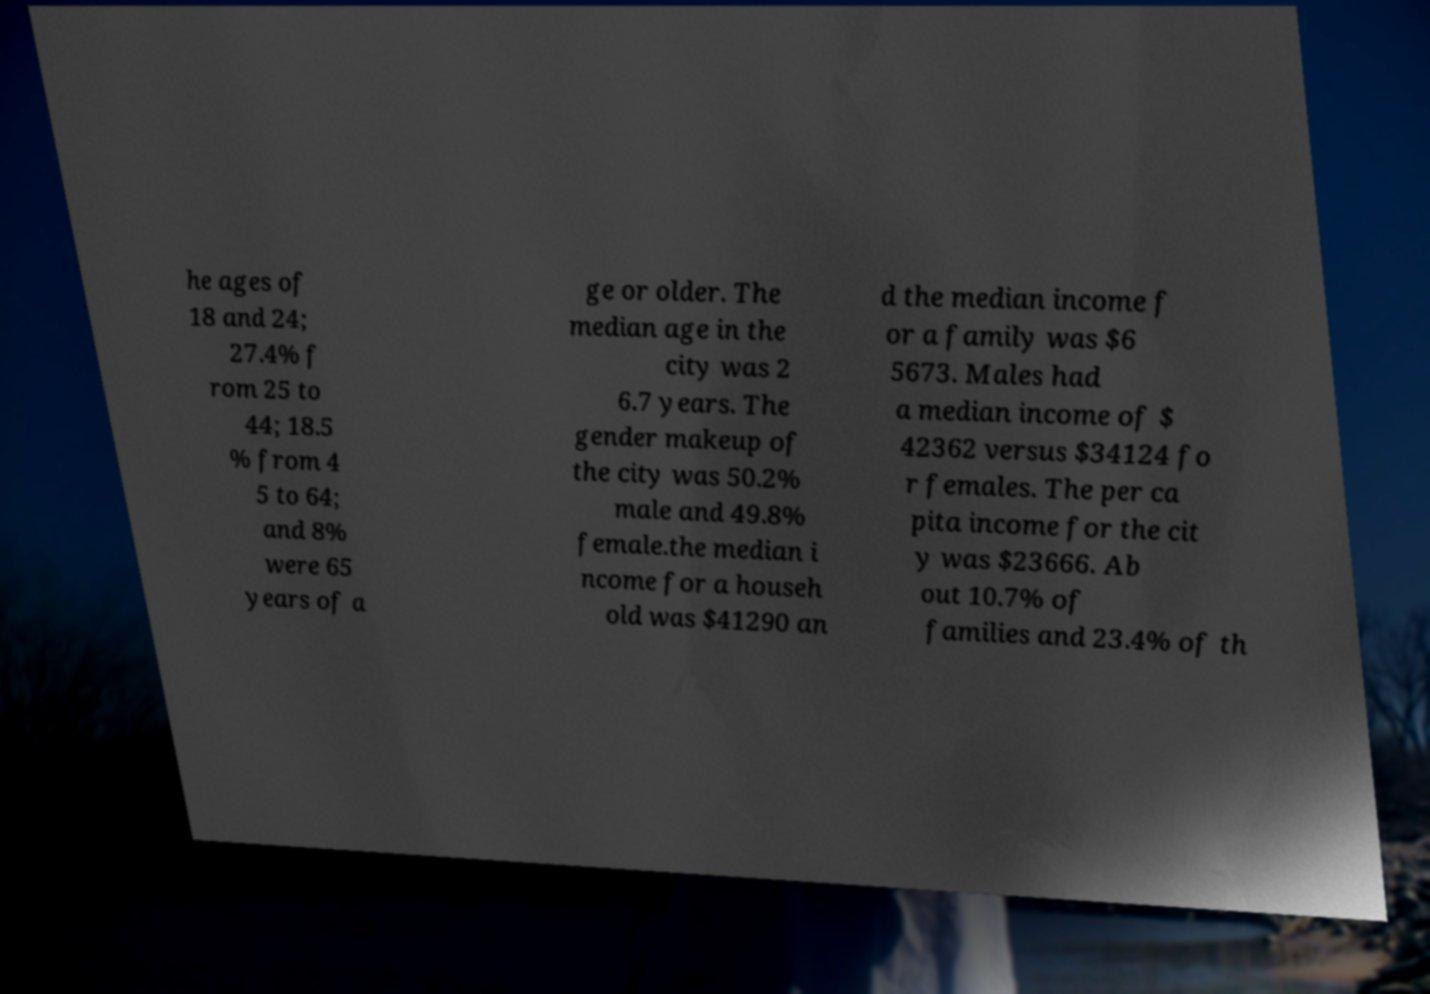Please identify and transcribe the text found in this image. he ages of 18 and 24; 27.4% f rom 25 to 44; 18.5 % from 4 5 to 64; and 8% were 65 years of a ge or older. The median age in the city was 2 6.7 years. The gender makeup of the city was 50.2% male and 49.8% female.the median i ncome for a househ old was $41290 an d the median income f or a family was $6 5673. Males had a median income of $ 42362 versus $34124 fo r females. The per ca pita income for the cit y was $23666. Ab out 10.7% of families and 23.4% of th 